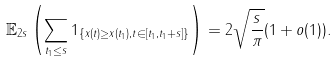<formula> <loc_0><loc_0><loc_500><loc_500>\mathbb { E } _ { 2 s } \left ( \sum _ { t _ { 1 } \leq s } 1 _ { \{ x ( t ) \geq x ( t _ { 1 } ) , t \in [ t _ { 1 } , t _ { 1 } + s ] \} } \right ) = 2 \sqrt { \frac { s } { \pi } } ( 1 + o ( 1 ) ) .</formula> 